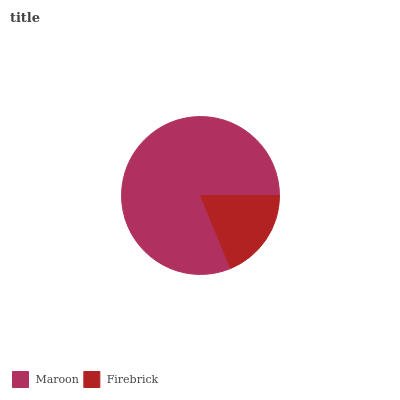Is Firebrick the minimum?
Answer yes or no. Yes. Is Maroon the maximum?
Answer yes or no. Yes. Is Firebrick the maximum?
Answer yes or no. No. Is Maroon greater than Firebrick?
Answer yes or no. Yes. Is Firebrick less than Maroon?
Answer yes or no. Yes. Is Firebrick greater than Maroon?
Answer yes or no. No. Is Maroon less than Firebrick?
Answer yes or no. No. Is Maroon the high median?
Answer yes or no. Yes. Is Firebrick the low median?
Answer yes or no. Yes. Is Firebrick the high median?
Answer yes or no. No. Is Maroon the low median?
Answer yes or no. No. 